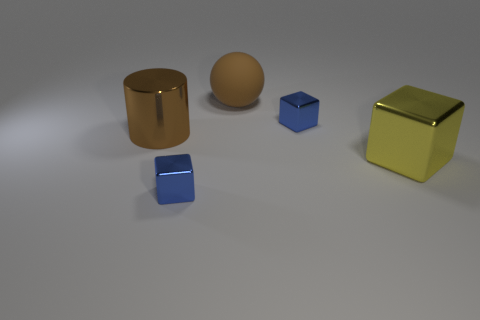Add 4 big blue metal cubes. How many objects exist? 9 Subtract all cubes. How many objects are left? 2 Subtract all large objects. Subtract all large purple objects. How many objects are left? 2 Add 3 blue cubes. How many blue cubes are left? 5 Add 2 big cylinders. How many big cylinders exist? 3 Subtract 1 brown balls. How many objects are left? 4 